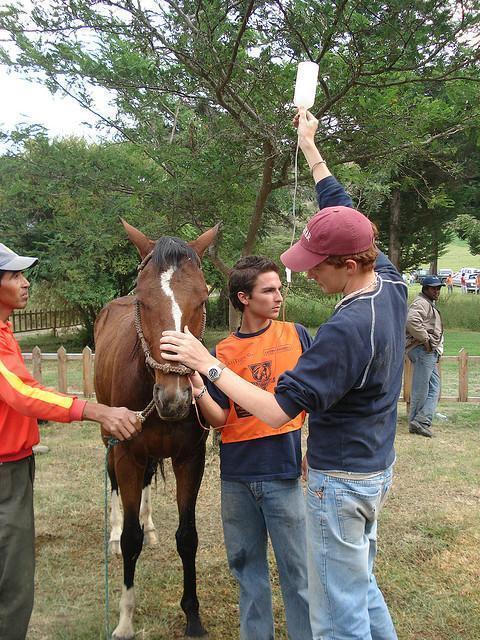What item is held up by the man here?
Indicate the correct response by choosing from the four available options to answer the question.
Options: Iv bag, poison, milk bottle, whiskey. Iv bag. 